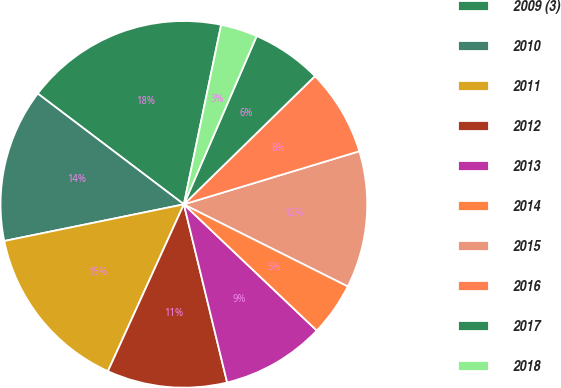<chart> <loc_0><loc_0><loc_500><loc_500><pie_chart><fcel>2009 (3)<fcel>2010<fcel>2011<fcel>2012<fcel>2013<fcel>2014<fcel>2015<fcel>2016<fcel>2017<fcel>2018<nl><fcel>17.94%<fcel>13.53%<fcel>15.0%<fcel>10.59%<fcel>9.12%<fcel>4.71%<fcel>12.06%<fcel>7.65%<fcel>6.18%<fcel>3.24%<nl></chart> 